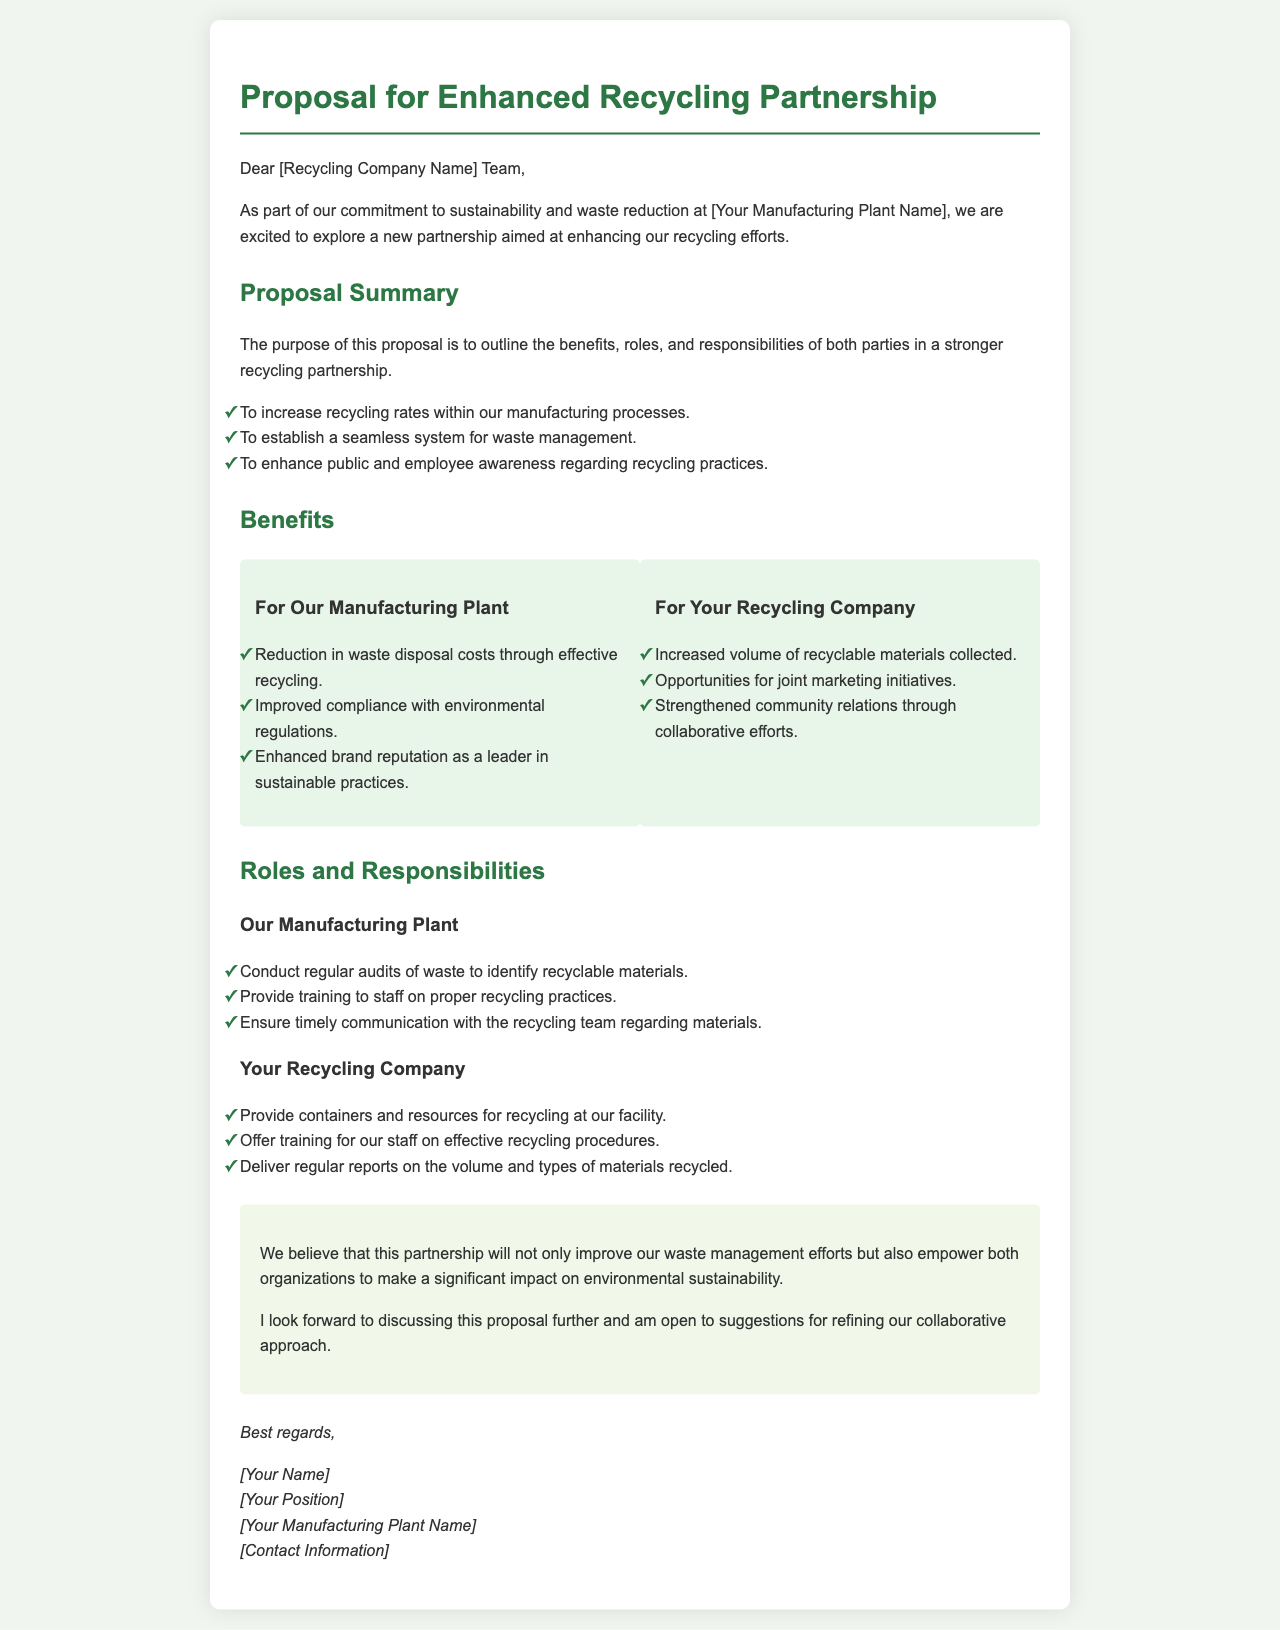What is the title of the proposal? The title of the proposal is located at the top of the document.
Answer: Proposal for Enhanced Recycling Partnership What are the three main goals of the proposal? The goals are outlined in the "Proposal Summary" section.
Answer: Increase recycling rates, establish a waste management system, enhance awareness What are two benefits for the manufacturing plant? The benefits for the manufacturing plant are listed in the section for that purpose.
Answer: Reduction in waste disposal costs, improved compliance with environmental regulations What type of training will the manufacturing plant provide? The training relates to staff responsibilities as mentioned in the roles section.
Answer: Proper recycling practices Who is responsible for delivering regular reports on materials recycled? The responsibility for delivering regular reports is specified under the recycling company's roles.
Answer: Your Recycling Company What should be conducted by the manufacturing plant regularly? The requirement for regular audits is detailed in the roles section for the manufacturing plant.
Answer: Audits of waste What color is used for section headings? The section headings' color can be identified by inspecting the styles in the document.
Answer: Green What is the overall aim of the proposed partnership? The aim of the partnership is summarized in the conclusion of the document.
Answer: Improve waste management efforts What will the recycling company provide for the facility? This information is explicitly mentioned in the roles of the recycling company.
Answer: Containers and resources for recycling 